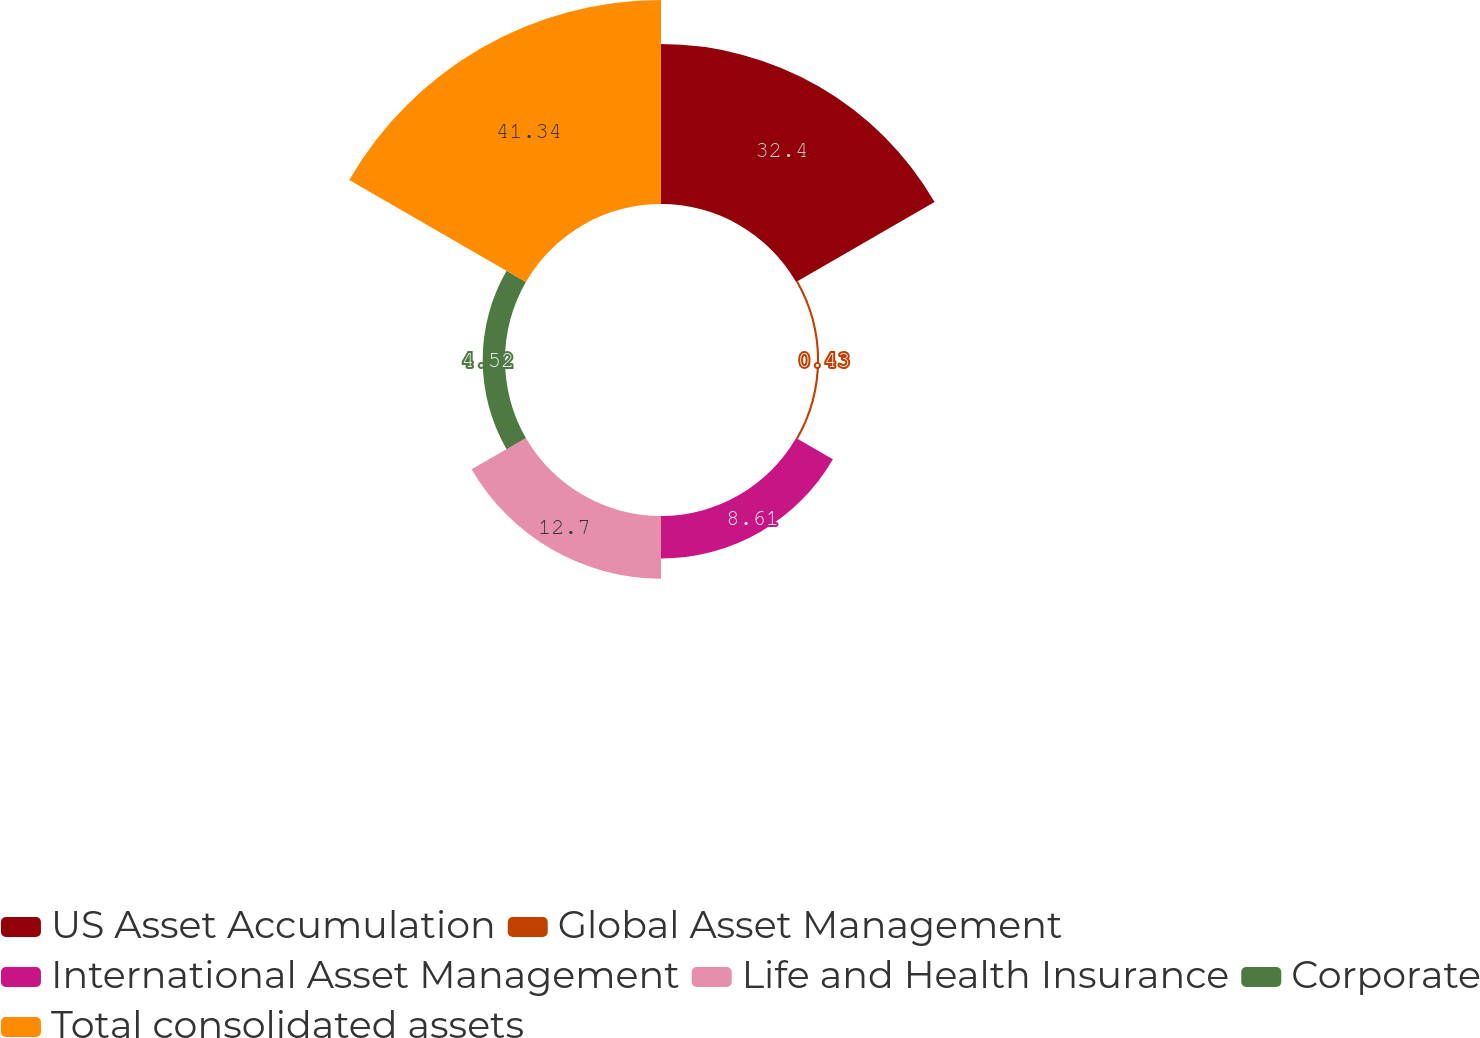<chart> <loc_0><loc_0><loc_500><loc_500><pie_chart><fcel>US Asset Accumulation<fcel>Global Asset Management<fcel>International Asset Management<fcel>Life and Health Insurance<fcel>Corporate<fcel>Total consolidated assets<nl><fcel>32.4%<fcel>0.43%<fcel>8.61%<fcel>12.7%<fcel>4.52%<fcel>41.34%<nl></chart> 